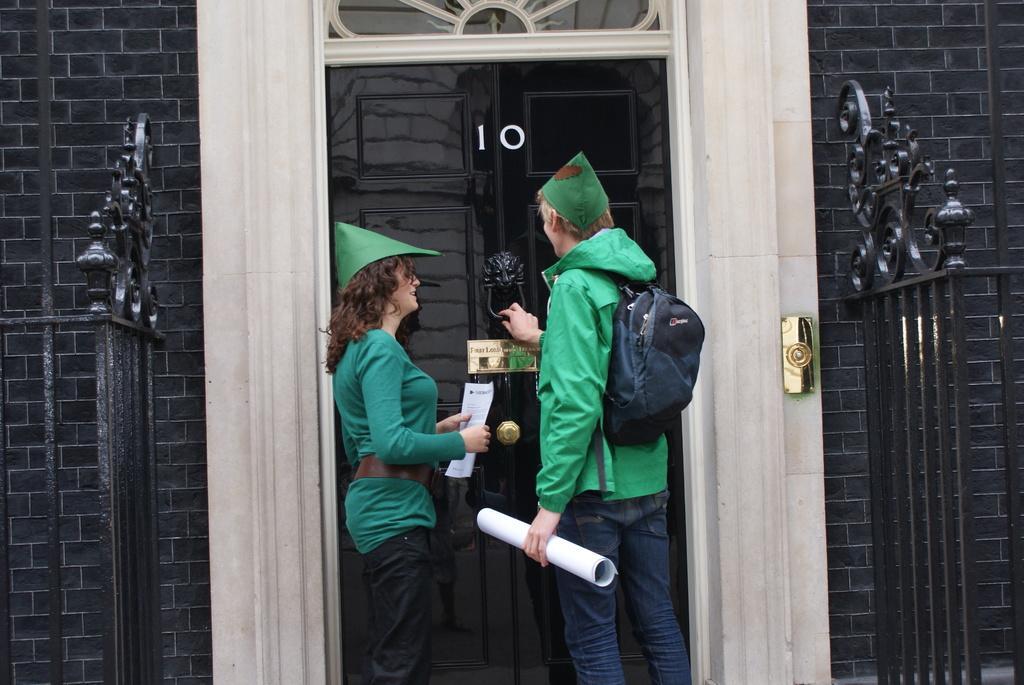Describe this image in one or two sentences. In this image in the front there are persons standing. On the left side there is a grill which is black in colour. On the right side there is black colour grill. In the background there is a building and there is a door. On the door there is some numbers written on it. 